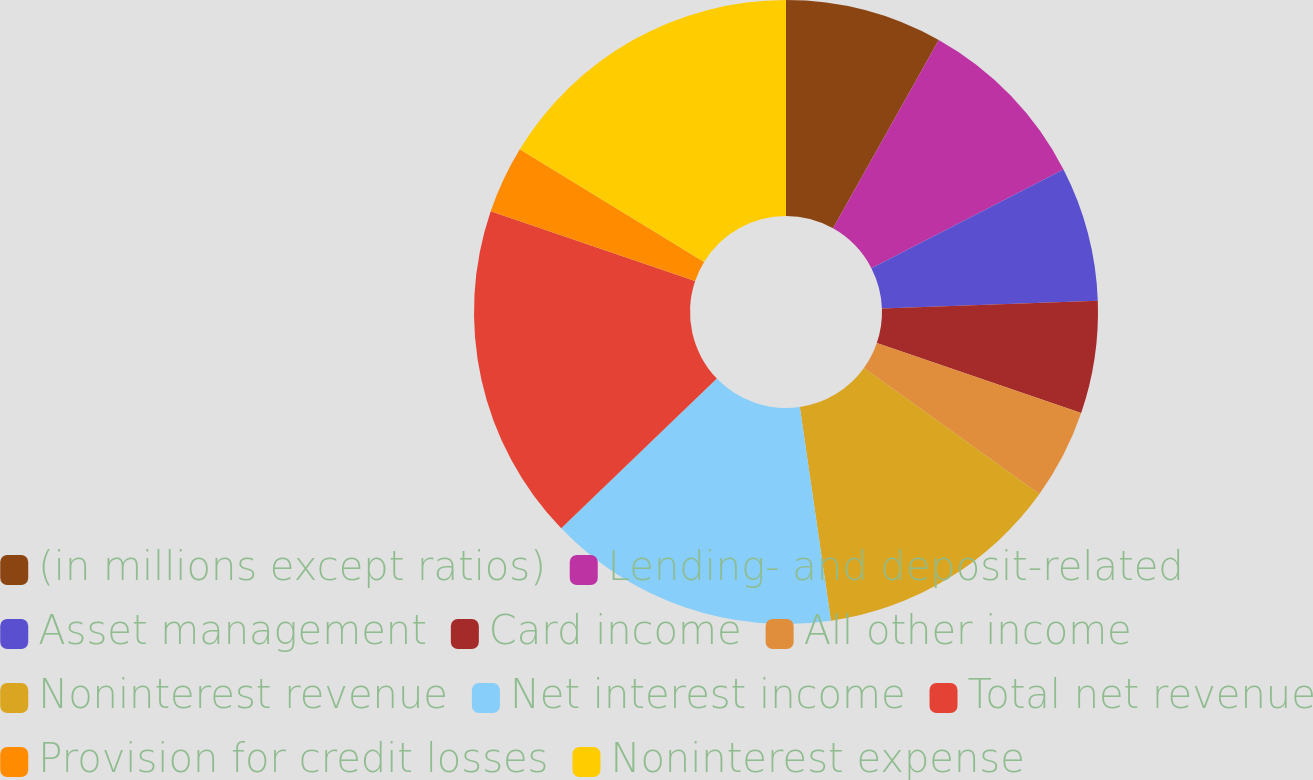Convert chart to OTSL. <chart><loc_0><loc_0><loc_500><loc_500><pie_chart><fcel>(in millions except ratios)<fcel>Lending- and deposit-related<fcel>Asset management<fcel>Card income<fcel>All other income<fcel>Noninterest revenue<fcel>Net interest income<fcel>Total net revenue<fcel>Provision for credit losses<fcel>Noninterest expense<nl><fcel>8.14%<fcel>9.3%<fcel>6.98%<fcel>5.82%<fcel>4.66%<fcel>12.78%<fcel>15.1%<fcel>17.42%<fcel>3.5%<fcel>16.26%<nl></chart> 